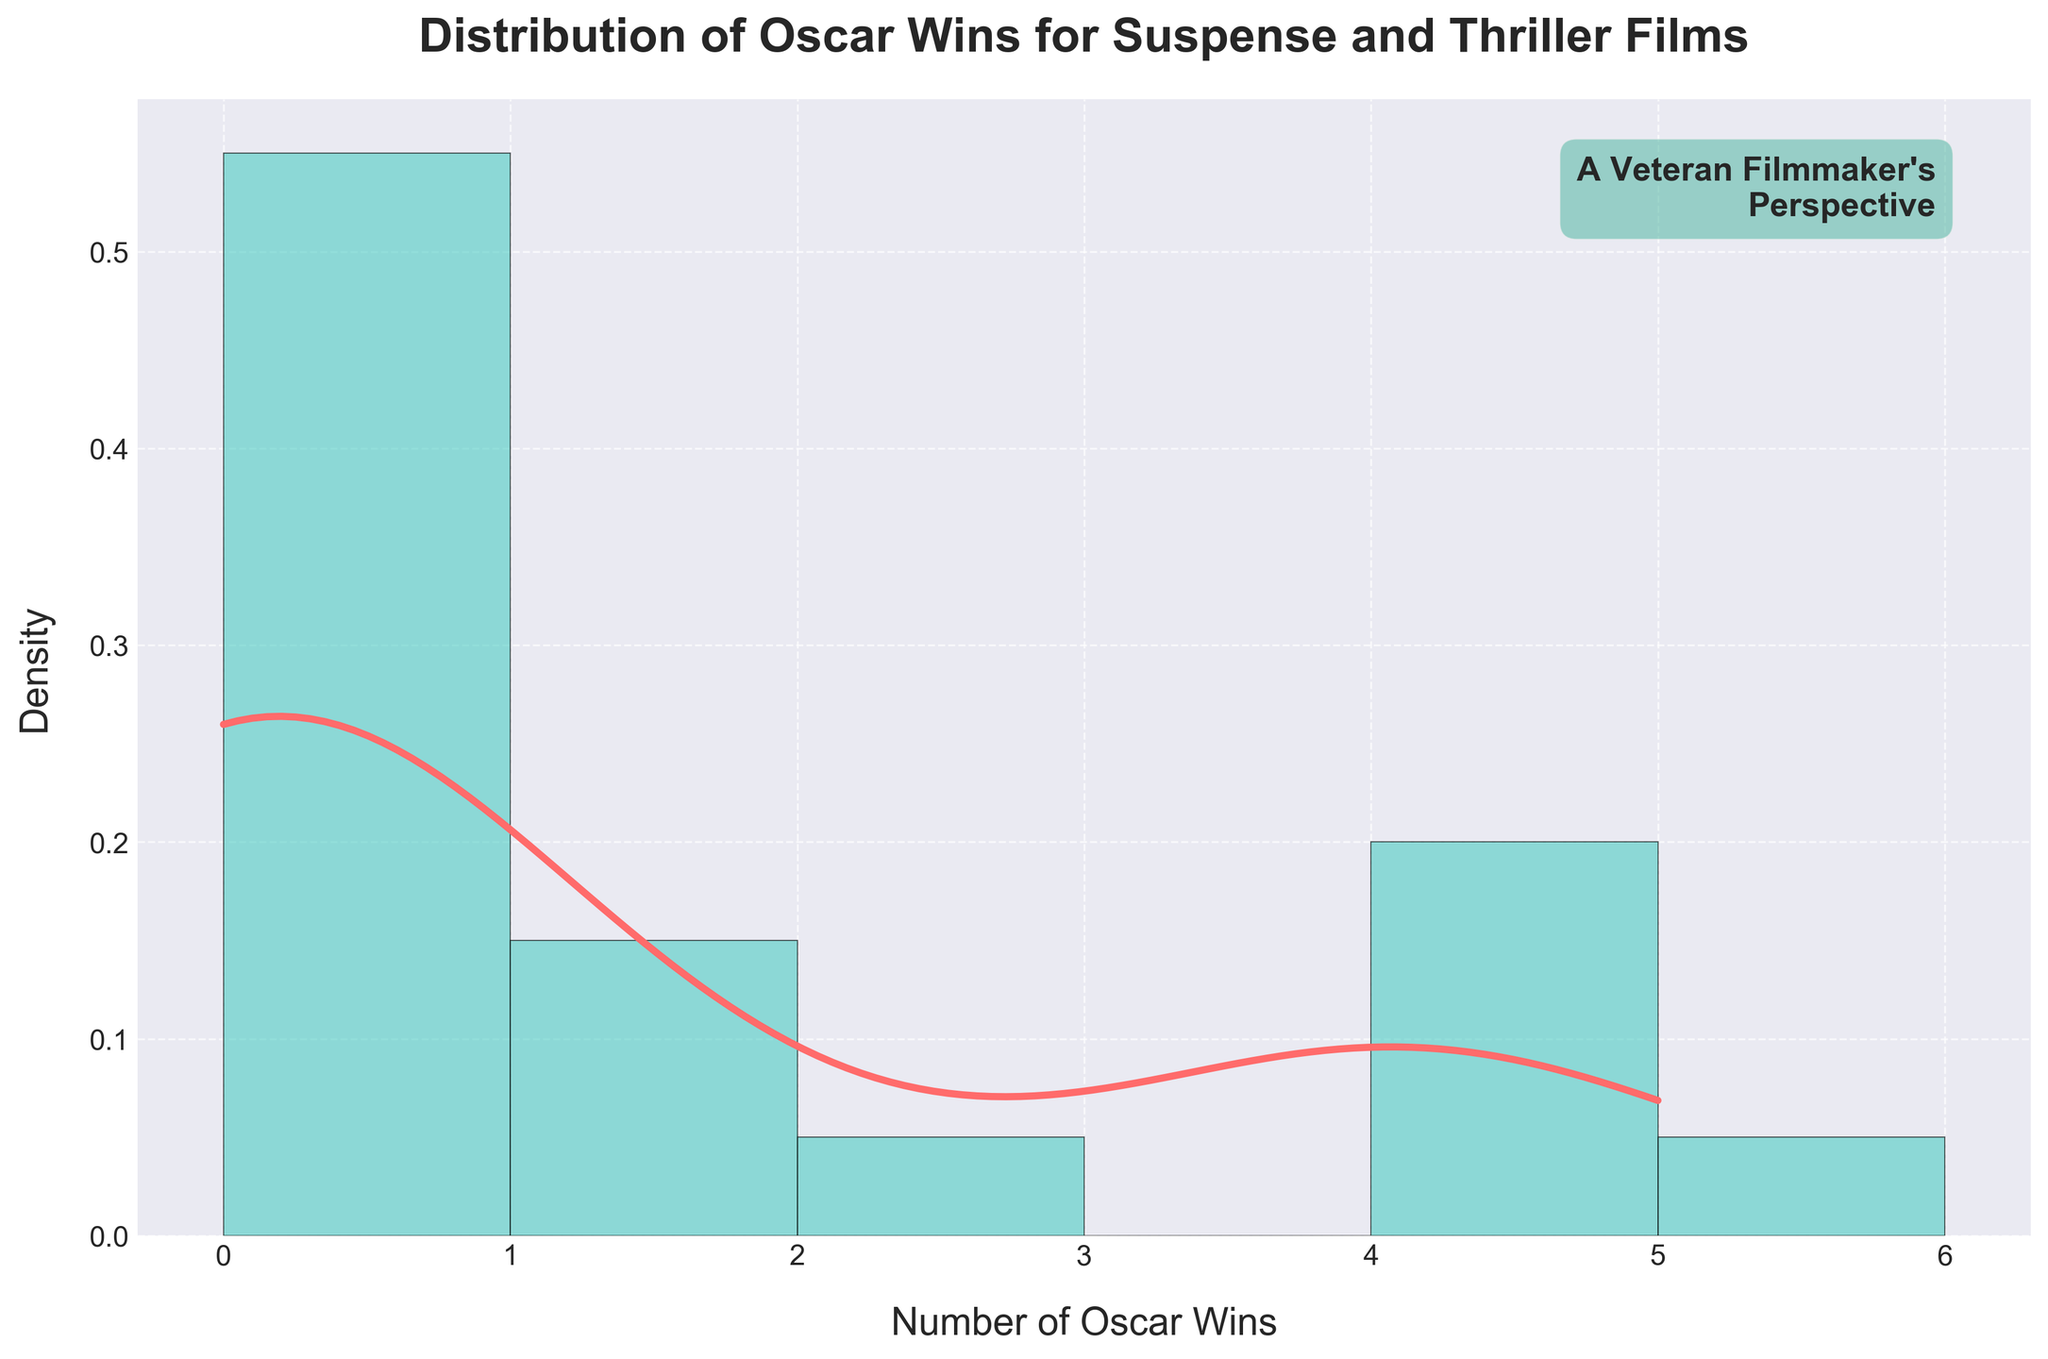What is the title of the plot? The title of the plot is located at the top of the figure.
Answer: Distribution of Oscar Wins for Suspense and Thriller Films What data distribution does the line represent? The line represents the data distribution using a Kernel Density Estimate (KDE), which shows the density of Oscar wins for suspense and thriller films.
Answer: Kernel Density Estimate (KDE) Which axis represents the number of Oscar wins? The x-axis represents the number of Oscar wins, as denoted by the label "Number of Oscar Wins."
Answer: x-axis What is the maximum number of Oscar wins shown on the x-axis? The x-axis ranges up to a maximum of 5 Oscar wins, as indicated by the axis labels.
Answer: 5 How many genres are being analyzed in this plot? There are two genres being analyzed: Suspense and Thriller. This can be inferred from the labeling and emphasis on those film genres in the plot's title and subtitle.
Answer: 2 What color represents the histogram bars, and what do they signify? The histogram bars are represented by a teal color and signify the frequency distribution of the number of Oscar wins achieved by the films.
Answer: Teal What can be inferred about the density of Oscar wins for these genres? By analyzing the peak and the spread of the KDE line as well as the histogram, we can infer that most films in the Suspense and Thriller genres have won between 0 and 2 Oscars, with very few achieving 4 or 5 wins.
Answer: Most films won between 0 and 2 Oscars Which genre has more films with 4 or more Oscar wins, Suspense or Thriller? Based on the histogram and our knowledge of the dataset, we see films like "Inception," "The Departed," "No Country for Old Men," and "Parasite" which are Thrillers with high Oscar wins. None of the Suspense films listed have 4 or more wins.
Answer: Thriller What is the density of films with 0 Oscar wins? The height of the bars and the KDE peak at 0 indicate that a significant portion of the films won no Oscars. The exact density isn't specified but it's the highest bar on the plot.
Answer: Highest Which genre had the film with the highest number of Oscar wins in this dataset? The dataset indicates that "Silence of the Lambs," a Suspense film, had the highest number of Oscar wins with 5.
Answer: Suspense 